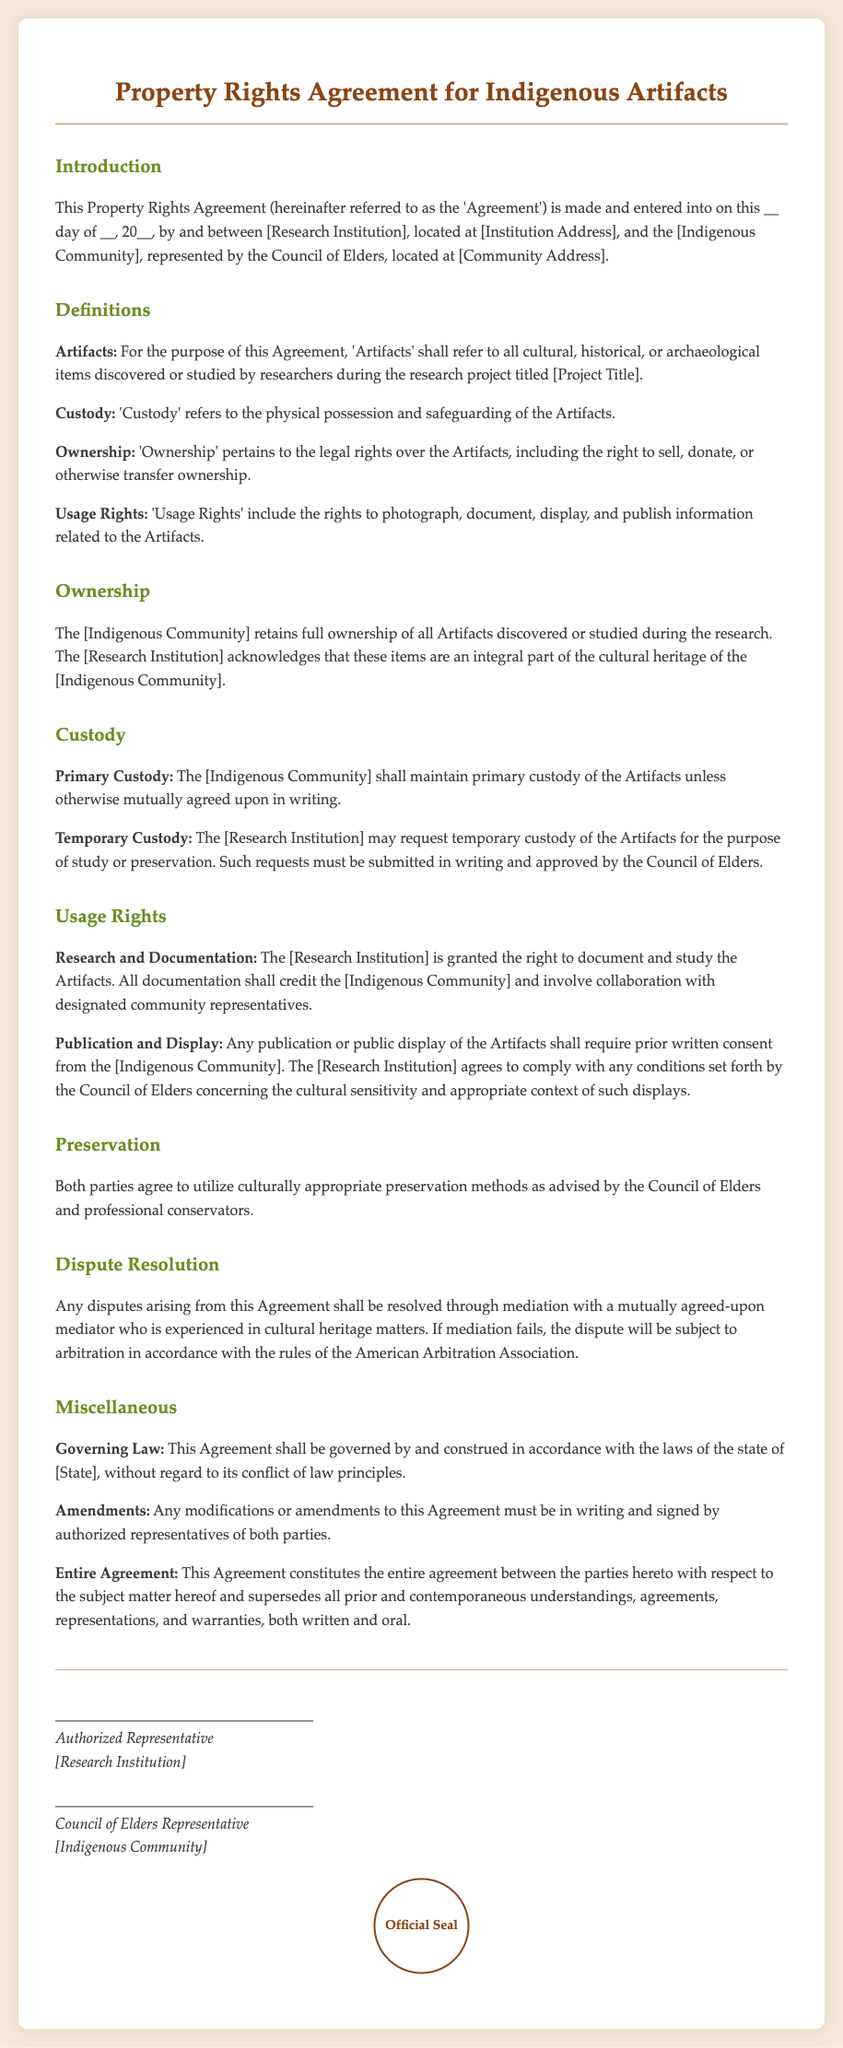What is the title of the document? The title of the document is presented at the top of the rendered document.
Answer: Property Rights Agreement for Indigenous Artifacts Who retains ownership of the artifacts? The ownership section of the document clearly states which party holds ownership of the artifacts.
Answer: Indigenous Community What is required for temporary custody requests? The document specifies the process by which temporary custody requests must be made and approved.
Answer: Written approval by the Council of Elders What must be credited in all documentation of the artifacts? The usage rights section indicates what must be acknowledged in the documentation process.
Answer: Indigenous Community What will be used for dispute resolution? The document outlines the process that will be followed for dispute resolution.
Answer: Mediation When should amendments to the agreement be made? The miscellaneous section specifies when modifications to the agreement can occur.
Answer: In writing and signed by authorized representatives What is to be utilized for preservation methods? The preservation section indicates what types of methods are to be used.
Answer: Culturally appropriate preservation methods 